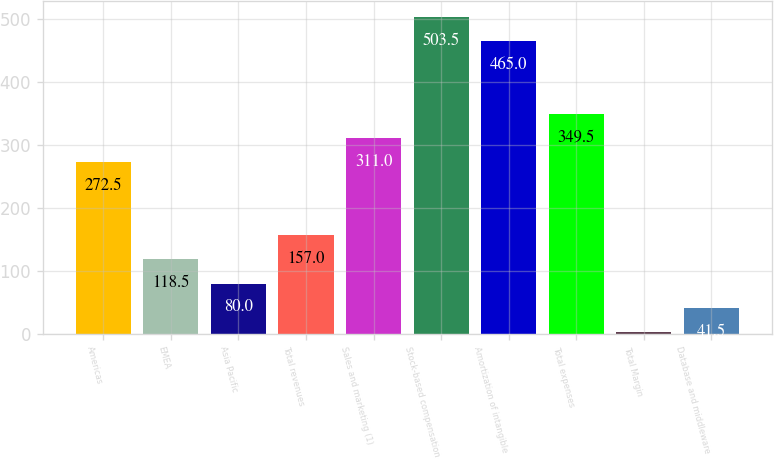Convert chart to OTSL. <chart><loc_0><loc_0><loc_500><loc_500><bar_chart><fcel>Americas<fcel>EMEA<fcel>Asia Pacific<fcel>Total revenues<fcel>Sales and marketing (1)<fcel>Stock-based compensation<fcel>Amortization of intangible<fcel>Total expenses<fcel>Total Margin<fcel>Database and middleware<nl><fcel>272.5<fcel>118.5<fcel>80<fcel>157<fcel>311<fcel>503.5<fcel>465<fcel>349.5<fcel>3<fcel>41.5<nl></chart> 